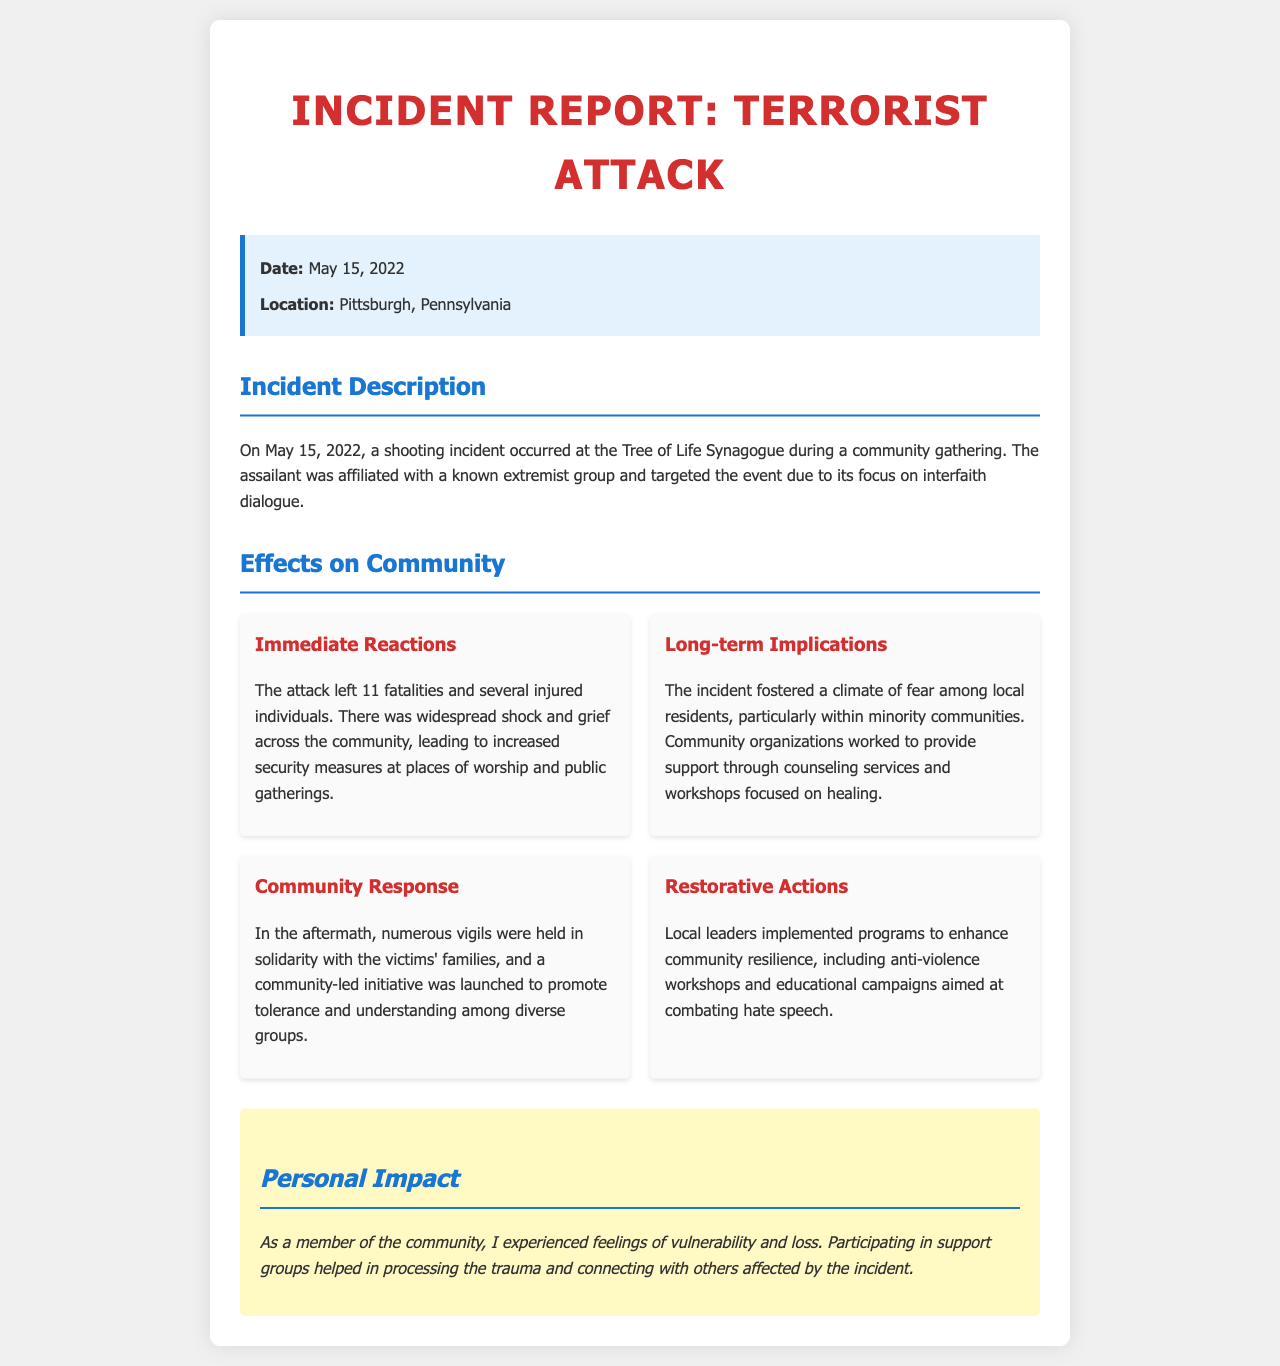What is the date of the incident? The date of the incident is explicitly stated in the document.
Answer: May 15, 2022 Where did the attack take place? The location of the incident is provided in the information box of the document.
Answer: Pittsburgh, Pennsylvania How many fatalities were reported? The document mentions the number of fatalities resulting from the attack.
Answer: 11 What kind of event was targeted? The incident description specifies the nature of the gathering at the synagogue.
Answer: Community gathering What emotional effects did the community experience? The document describes the feelings in the community after the incident.
Answer: Shock and grief What type of support was provided to the community? The document details the actions taken by organizations to aid the affected community.
Answer: Counseling services What was launched to promote tolerance? The community's response included initiatives to foster understanding, as outlined in the document.
Answer: Community-led initiative Which group was the assailant affiliated with? The incident description contains information on the assailant's background.
Answer: Known extremist group How did local leaders respond to the incident? The document mentions actions taken by local leaders for community resilience.
Answer: Implemented programs 